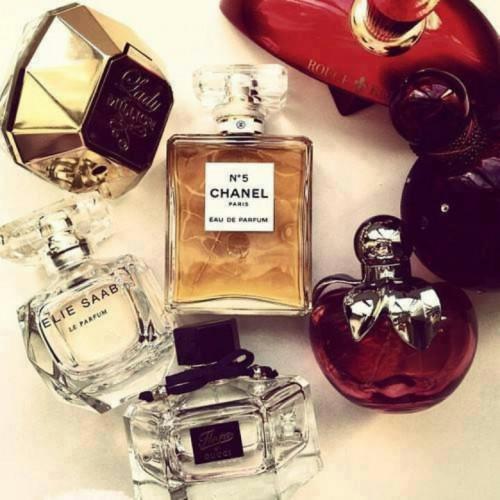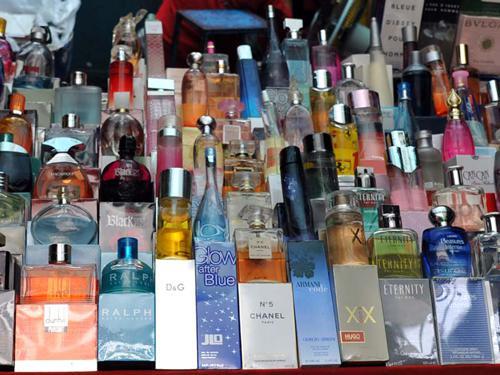The first image is the image on the left, the second image is the image on the right. Assess this claim about the two images: "The left image includes at least one round glass fragrance bottle but does not include any boxes.". Correct or not? Answer yes or no. Yes. The first image is the image on the left, the second image is the image on the right. Given the left and right images, does the statement "In the image on the right, perfumes are stacked in front of a bag." hold true? Answer yes or no. No. 